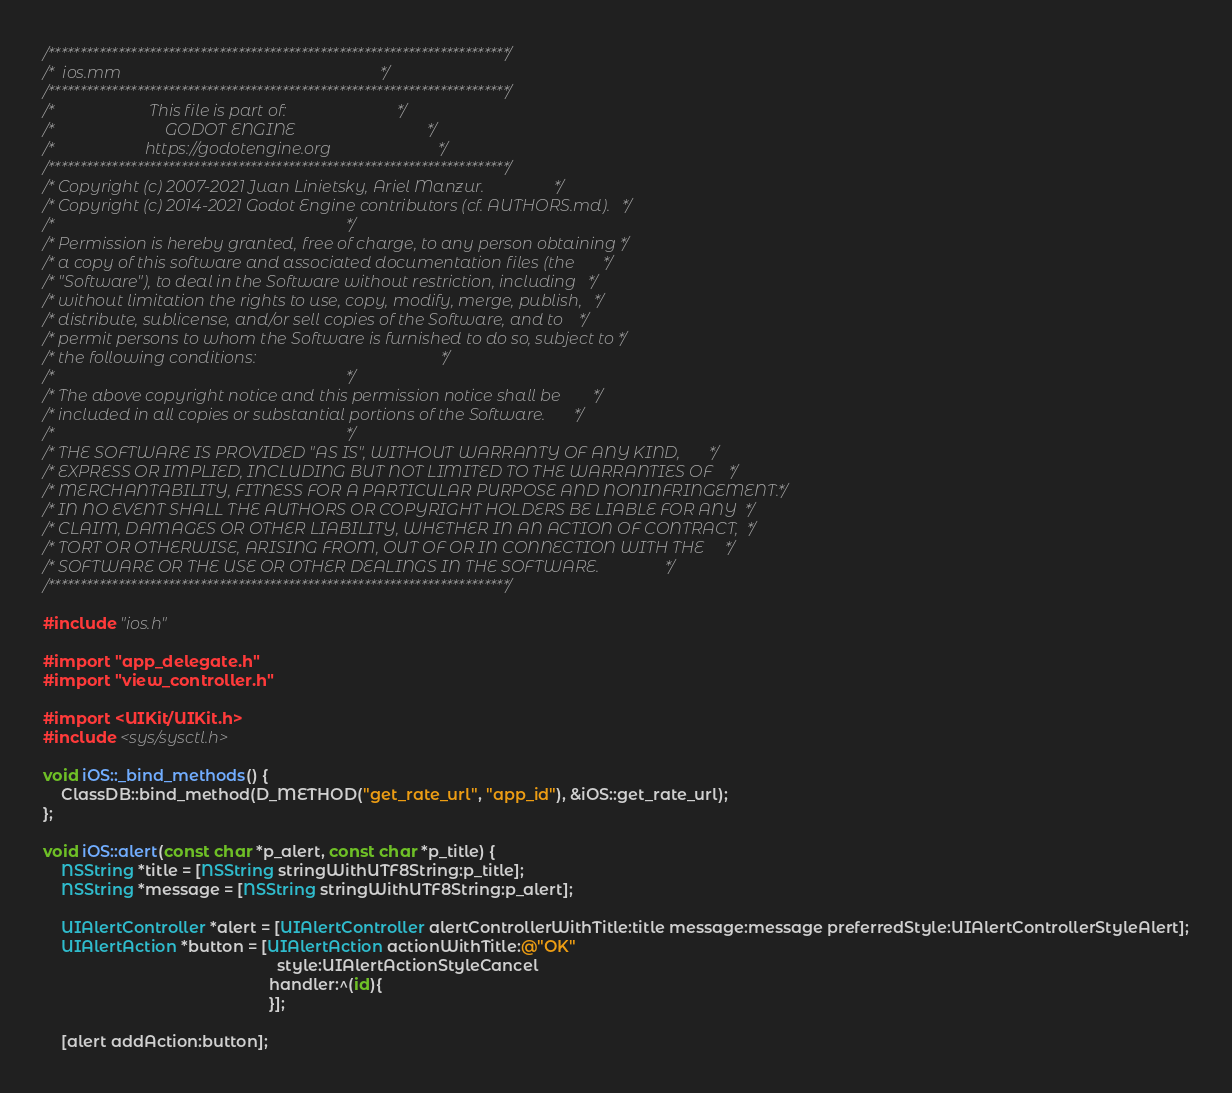<code> <loc_0><loc_0><loc_500><loc_500><_ObjectiveC_>/*************************************************************************/
/*  ios.mm                                                               */
/*************************************************************************/
/*                       This file is part of:                           */
/*                           GODOT ENGINE                                */
/*                      https://godotengine.org                          */
/*************************************************************************/
/* Copyright (c) 2007-2021 Juan Linietsky, Ariel Manzur.                 */
/* Copyright (c) 2014-2021 Godot Engine contributors (cf. AUTHORS.md).   */
/*                                                                       */
/* Permission is hereby granted, free of charge, to any person obtaining */
/* a copy of this software and associated documentation files (the       */
/* "Software"), to deal in the Software without restriction, including   */
/* without limitation the rights to use, copy, modify, merge, publish,   */
/* distribute, sublicense, and/or sell copies of the Software, and to    */
/* permit persons to whom the Software is furnished to do so, subject to */
/* the following conditions:                                             */
/*                                                                       */
/* The above copyright notice and this permission notice shall be        */
/* included in all copies or substantial portions of the Software.       */
/*                                                                       */
/* THE SOFTWARE IS PROVIDED "AS IS", WITHOUT WARRANTY OF ANY KIND,       */
/* EXPRESS OR IMPLIED, INCLUDING BUT NOT LIMITED TO THE WARRANTIES OF    */
/* MERCHANTABILITY, FITNESS FOR A PARTICULAR PURPOSE AND NONINFRINGEMENT.*/
/* IN NO EVENT SHALL THE AUTHORS OR COPYRIGHT HOLDERS BE LIABLE FOR ANY  */
/* CLAIM, DAMAGES OR OTHER LIABILITY, WHETHER IN AN ACTION OF CONTRACT,  */
/* TORT OR OTHERWISE, ARISING FROM, OUT OF OR IN CONNECTION WITH THE     */
/* SOFTWARE OR THE USE OR OTHER DEALINGS IN THE SOFTWARE.                */
/*************************************************************************/

#include "ios.h"

#import "app_delegate.h"
#import "view_controller.h"

#import <UIKit/UIKit.h>
#include <sys/sysctl.h>

void iOS::_bind_methods() {
	ClassDB::bind_method(D_METHOD("get_rate_url", "app_id"), &iOS::get_rate_url);
};

void iOS::alert(const char *p_alert, const char *p_title) {
	NSString *title = [NSString stringWithUTF8String:p_title];
	NSString *message = [NSString stringWithUTF8String:p_alert];

	UIAlertController *alert = [UIAlertController alertControllerWithTitle:title message:message preferredStyle:UIAlertControllerStyleAlert];
	UIAlertAction *button = [UIAlertAction actionWithTitle:@"OK"
													 style:UIAlertActionStyleCancel
												   handler:^(id){
												   }];

	[alert addAction:button];
</code> 